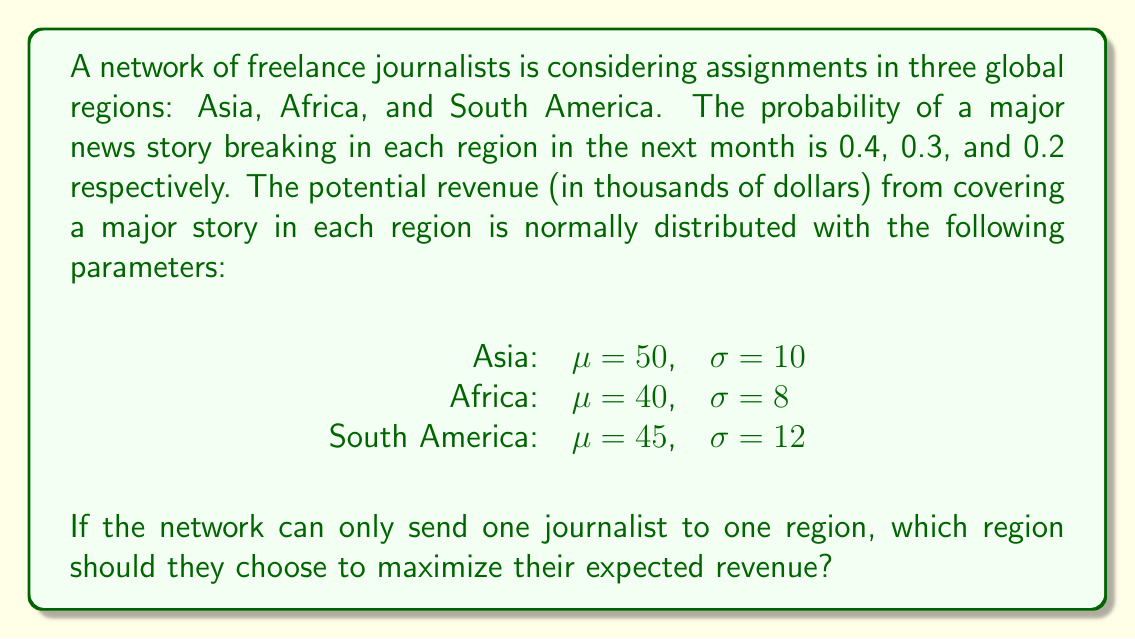Give your solution to this math problem. To determine the optimal region for assignment, we need to calculate the expected value of revenue for each region. The expected value is the product of the probability of a major news story occurring and the mean potential revenue from covering that story.

1. For Asia:
   Expected Value = Probability × Mean Revenue
   $EV_{Asia} = 0.4 \times 50 = 20$ thousand dollars

2. For Africa:
   $EV_{Africa} = 0.3 \times 40 = 12$ thousand dollars

3. For South America:
   $EV_{South America} = 0.2 \times 45 = 9$ thousand dollars

Comparing the expected values:
$EV_{Asia} > EV_{Africa} > EV_{South America}$

Therefore, to maximize expected revenue, the network should send the journalist to Asia.

Note: The standard deviations ($\sigma$) provided in the question do not affect the decision in this case, as we are only concerned with expected values. However, they would be relevant if we were considering risk or the probability of exceeding a certain revenue threshold.
Answer: Asia 